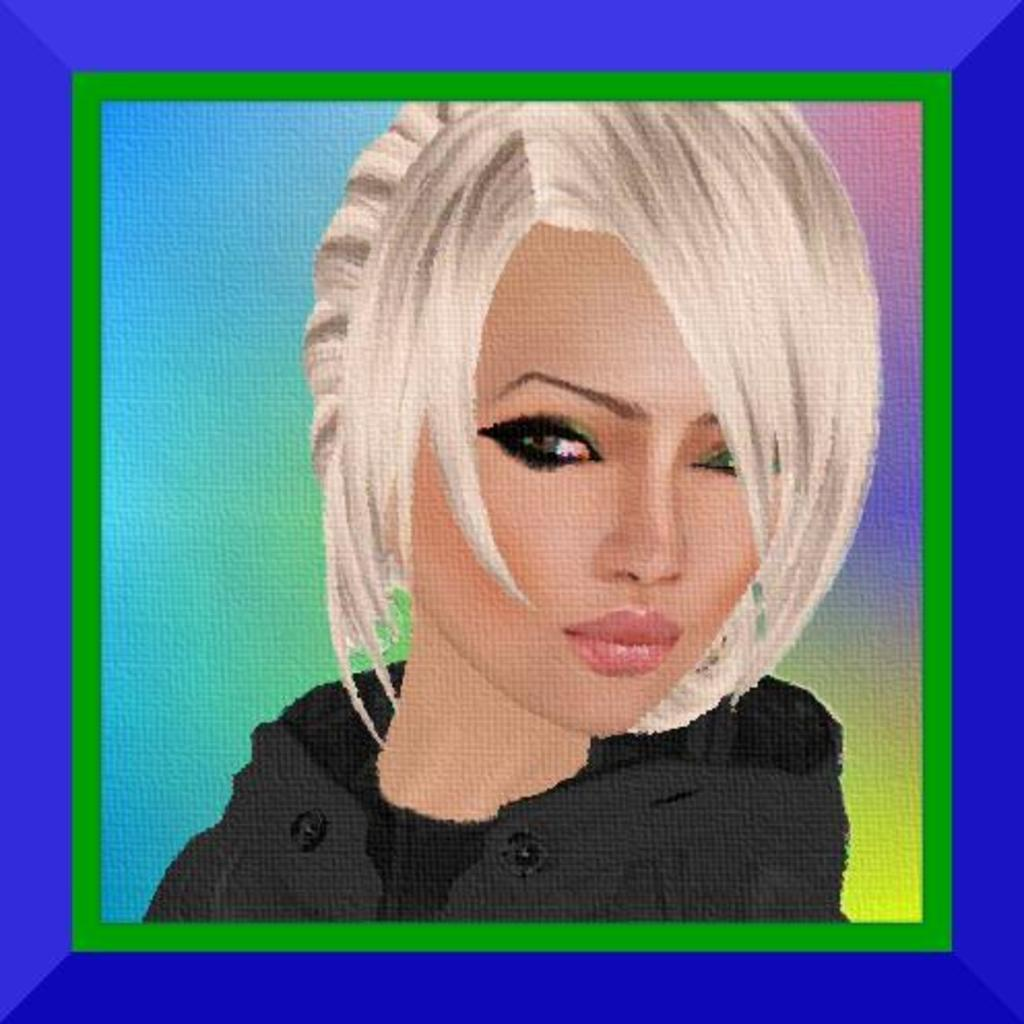Who is the main subject in the foreground of the image? There is a woman in the foreground of the image. Can you describe the woman's hair in the image? The woman has short hair. What type of clothing is the woman wearing in the image? The woman is wearing a coat. What can be seen in the background of the image? The background of the image is colorful. What type of surprise can be seen in the woman's hand in the image? There is no surprise visible in the woman's hand in the image. How does the woman slip on the ice in the image? There is no ice or slipping depicted in the image; the woman is standing still. 